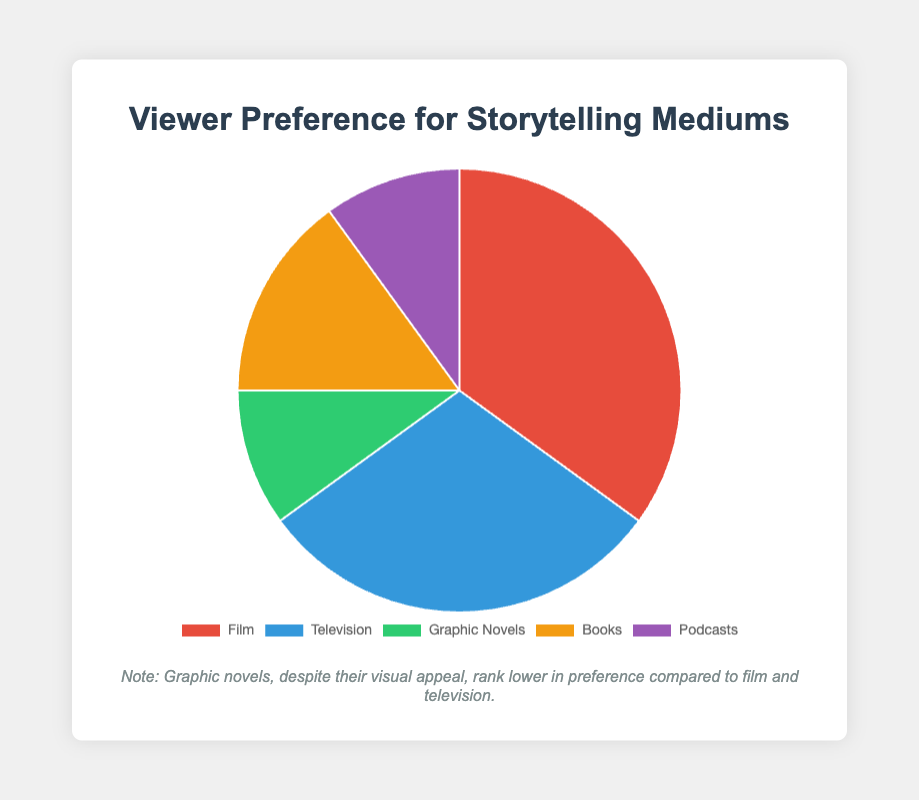What percentage of viewers prefer film over graphic novels? To determine the percentage of viewers that prefer film over graphic novels, compare the values directly from the pie chart: Film (35%) and Graphic Novels (10%). Therefore, the percentage of viewers that prefer film is 35%.
Answer: 35% What is the total percentage of viewers that prefer either books or podcasts? To calculate the total percentage for books and podcasts, add their respective percentages: Books (15%) + Podcasts (10%) = 25%.
Answer: 25% How much more popular is film compared to books? To determine how much more popular film is compared to books, subtract the percentage of books from the percentage of film: Film (35%) - Books (15%) = 20%.
Answer: 20% Which storytelling medium is the least preferred, and by how much? From the pie chart, both Graphic Novels and Podcasts are equally the least preferred mediums, each with 10%.
Answer: Graphic Novels and Podcasts (10%) Combine the viewer preferences for television and graphic novels. What percentage does it represent? Add the percentages of television and graphic novels: Television (30%) + Graphic Novels (10%) = 40%.
Answer: 40% What color represents the segment for books, and what percentage does it account for? The segment for books is represented in yellow and accounts for 15% of the viewer preferences.
Answer: Yellow, 15% Is there a bigger difference in preference between film and television, or between books and graphic novels? Calculate the difference for each pair: Film and Television (35% - 30% = 5%), Books and Graphic Novels (15% - 10% = 5%). Both differences are 5%.
Answer: Both differences are 5% What fraction of viewers prefer graphic novels out of all the viewers? The percentage of viewers that prefer graphic novels is 10%. Convert this percentage to a fraction: 10/100 = 1/10.
Answer: 1/10 Compared to books, by what percentage is television more preferred? Subtract the percentage of books from the percentage of television: Television (30%) - Books (15%) = 15%.
Answer: 15% 